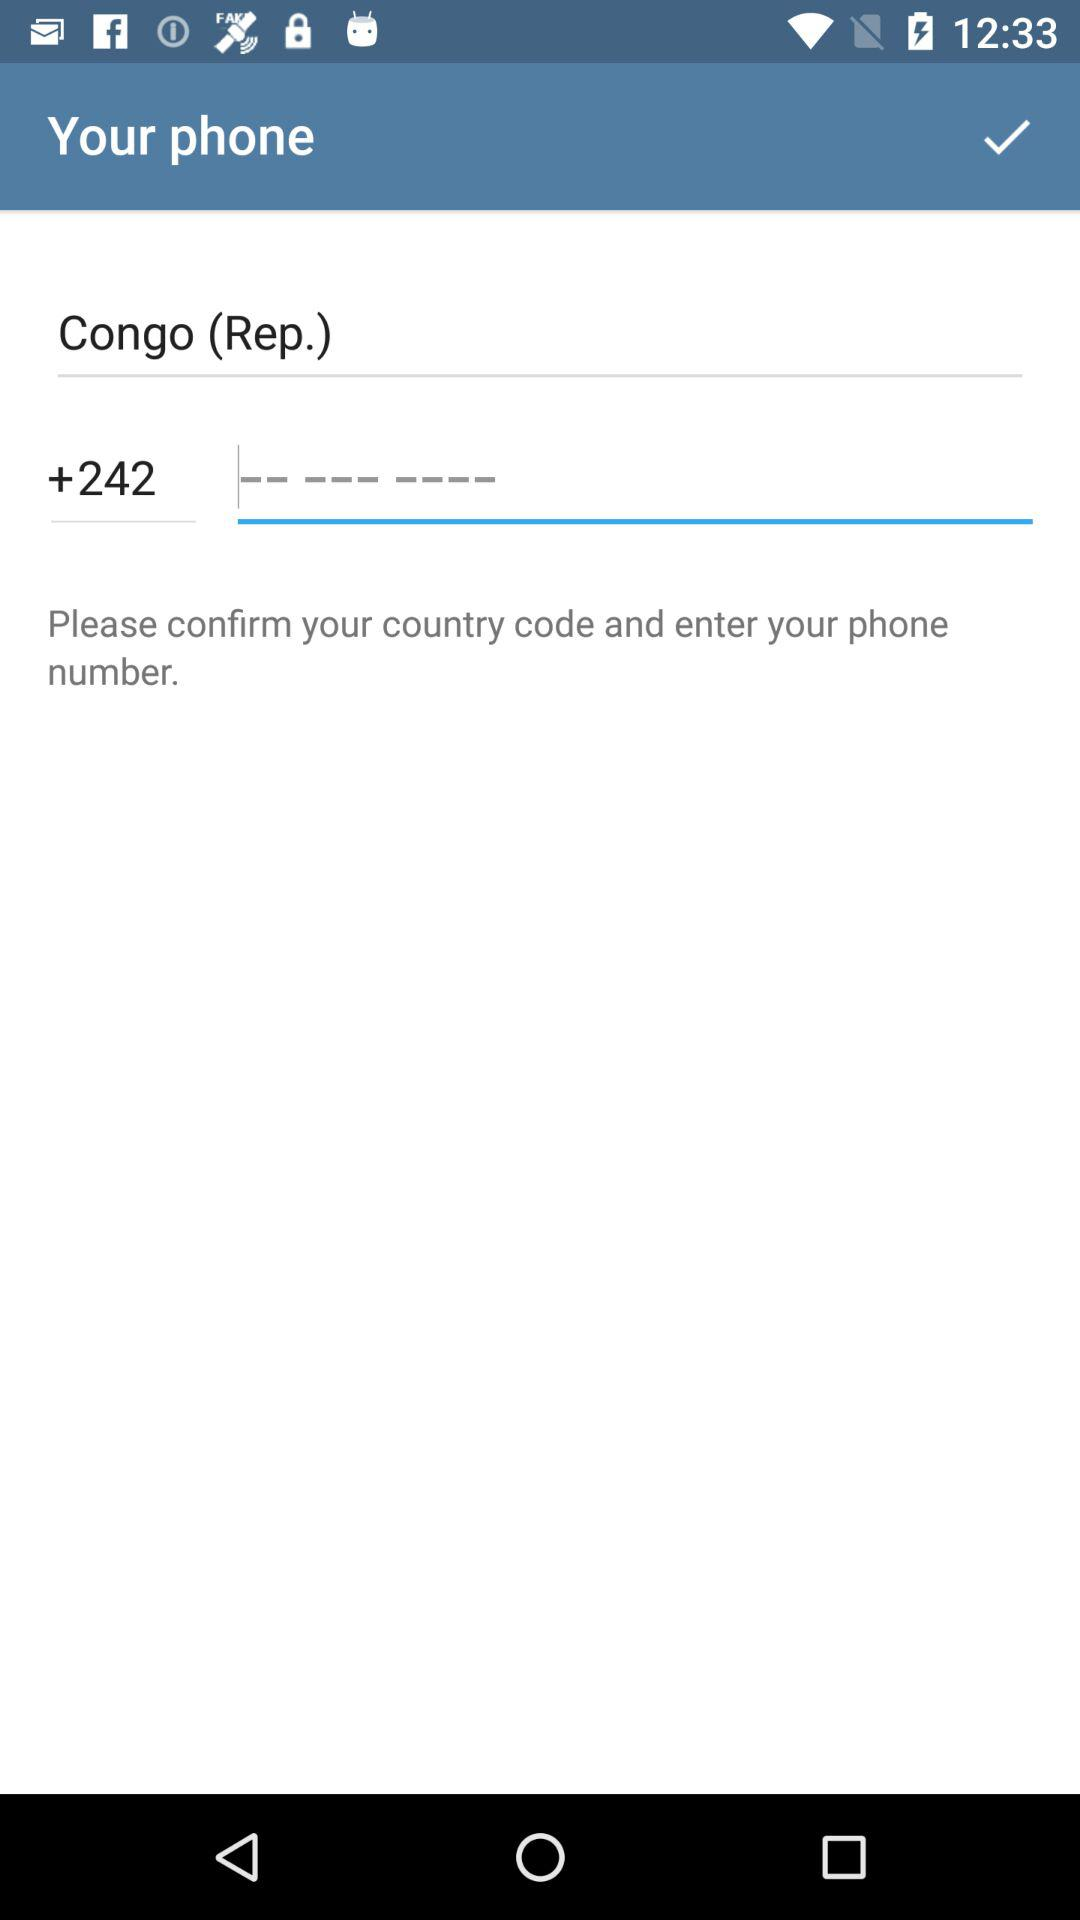What is the country code? The country code is "+242". 